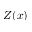Convert formula to latex. <formula><loc_0><loc_0><loc_500><loc_500>Z ( x )</formula> 